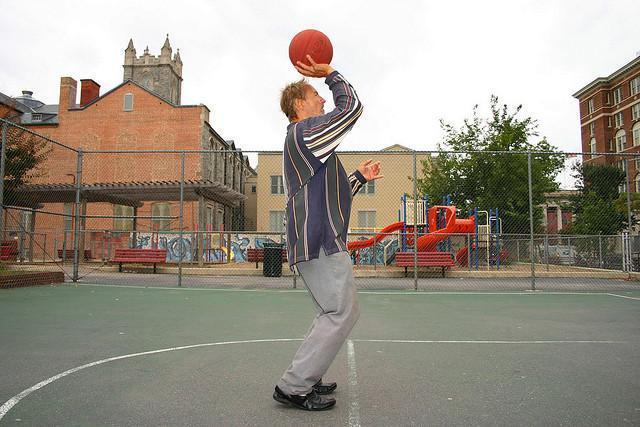How many people are there?
Give a very brief answer. 1. 